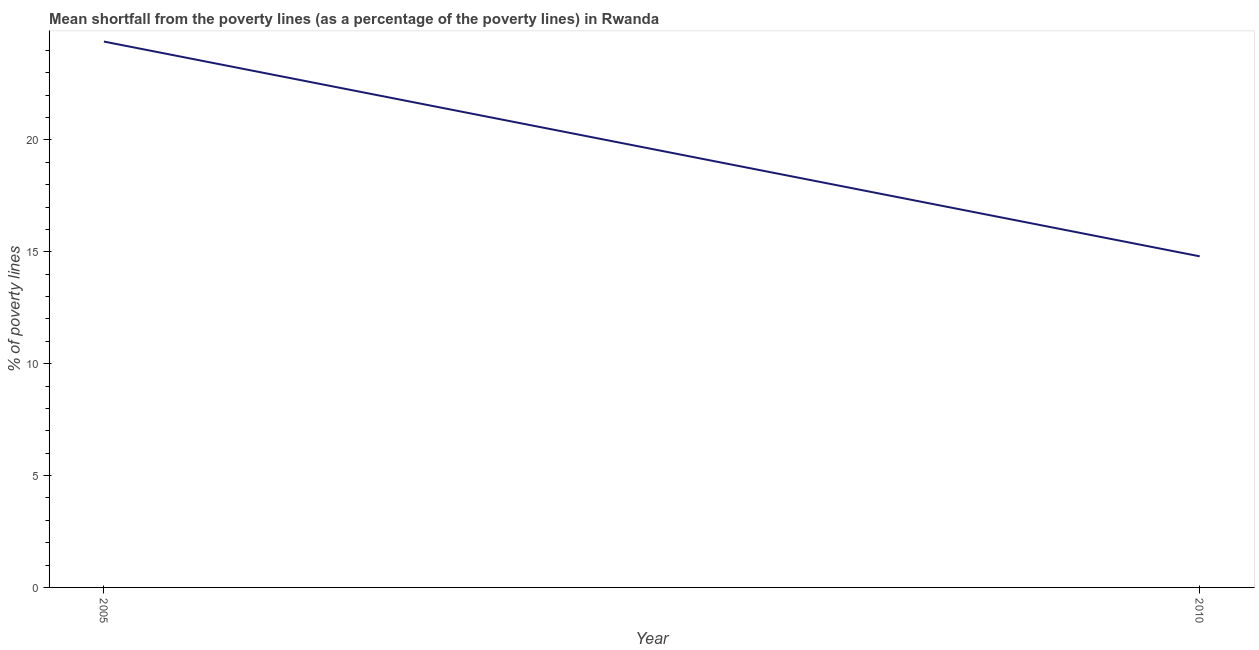Across all years, what is the maximum poverty gap at national poverty lines?
Offer a very short reply. 24.4. In which year was the poverty gap at national poverty lines maximum?
Provide a short and direct response. 2005. What is the sum of the poverty gap at national poverty lines?
Provide a succinct answer. 39.2. What is the difference between the poverty gap at national poverty lines in 2005 and 2010?
Offer a terse response. 9.6. What is the average poverty gap at national poverty lines per year?
Give a very brief answer. 19.6. What is the median poverty gap at national poverty lines?
Ensure brevity in your answer.  19.6. What is the ratio of the poverty gap at national poverty lines in 2005 to that in 2010?
Your response must be concise. 1.65. Does the poverty gap at national poverty lines monotonically increase over the years?
Provide a succinct answer. No. How many lines are there?
Give a very brief answer. 1. Does the graph contain grids?
Provide a short and direct response. No. What is the title of the graph?
Provide a short and direct response. Mean shortfall from the poverty lines (as a percentage of the poverty lines) in Rwanda. What is the label or title of the X-axis?
Your response must be concise. Year. What is the label or title of the Y-axis?
Provide a short and direct response. % of poverty lines. What is the % of poverty lines of 2005?
Provide a succinct answer. 24.4. What is the ratio of the % of poverty lines in 2005 to that in 2010?
Provide a short and direct response. 1.65. 